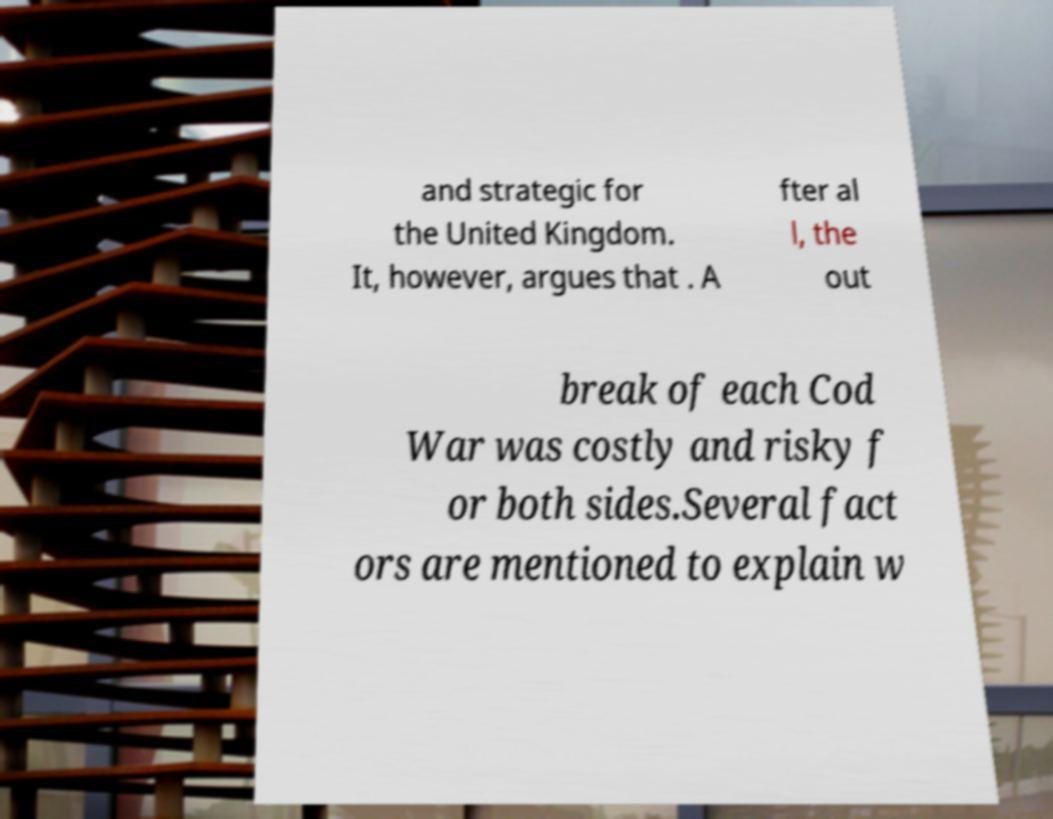Please identify and transcribe the text found in this image. and strategic for the United Kingdom. It, however, argues that . A fter al l, the out break of each Cod War was costly and risky f or both sides.Several fact ors are mentioned to explain w 